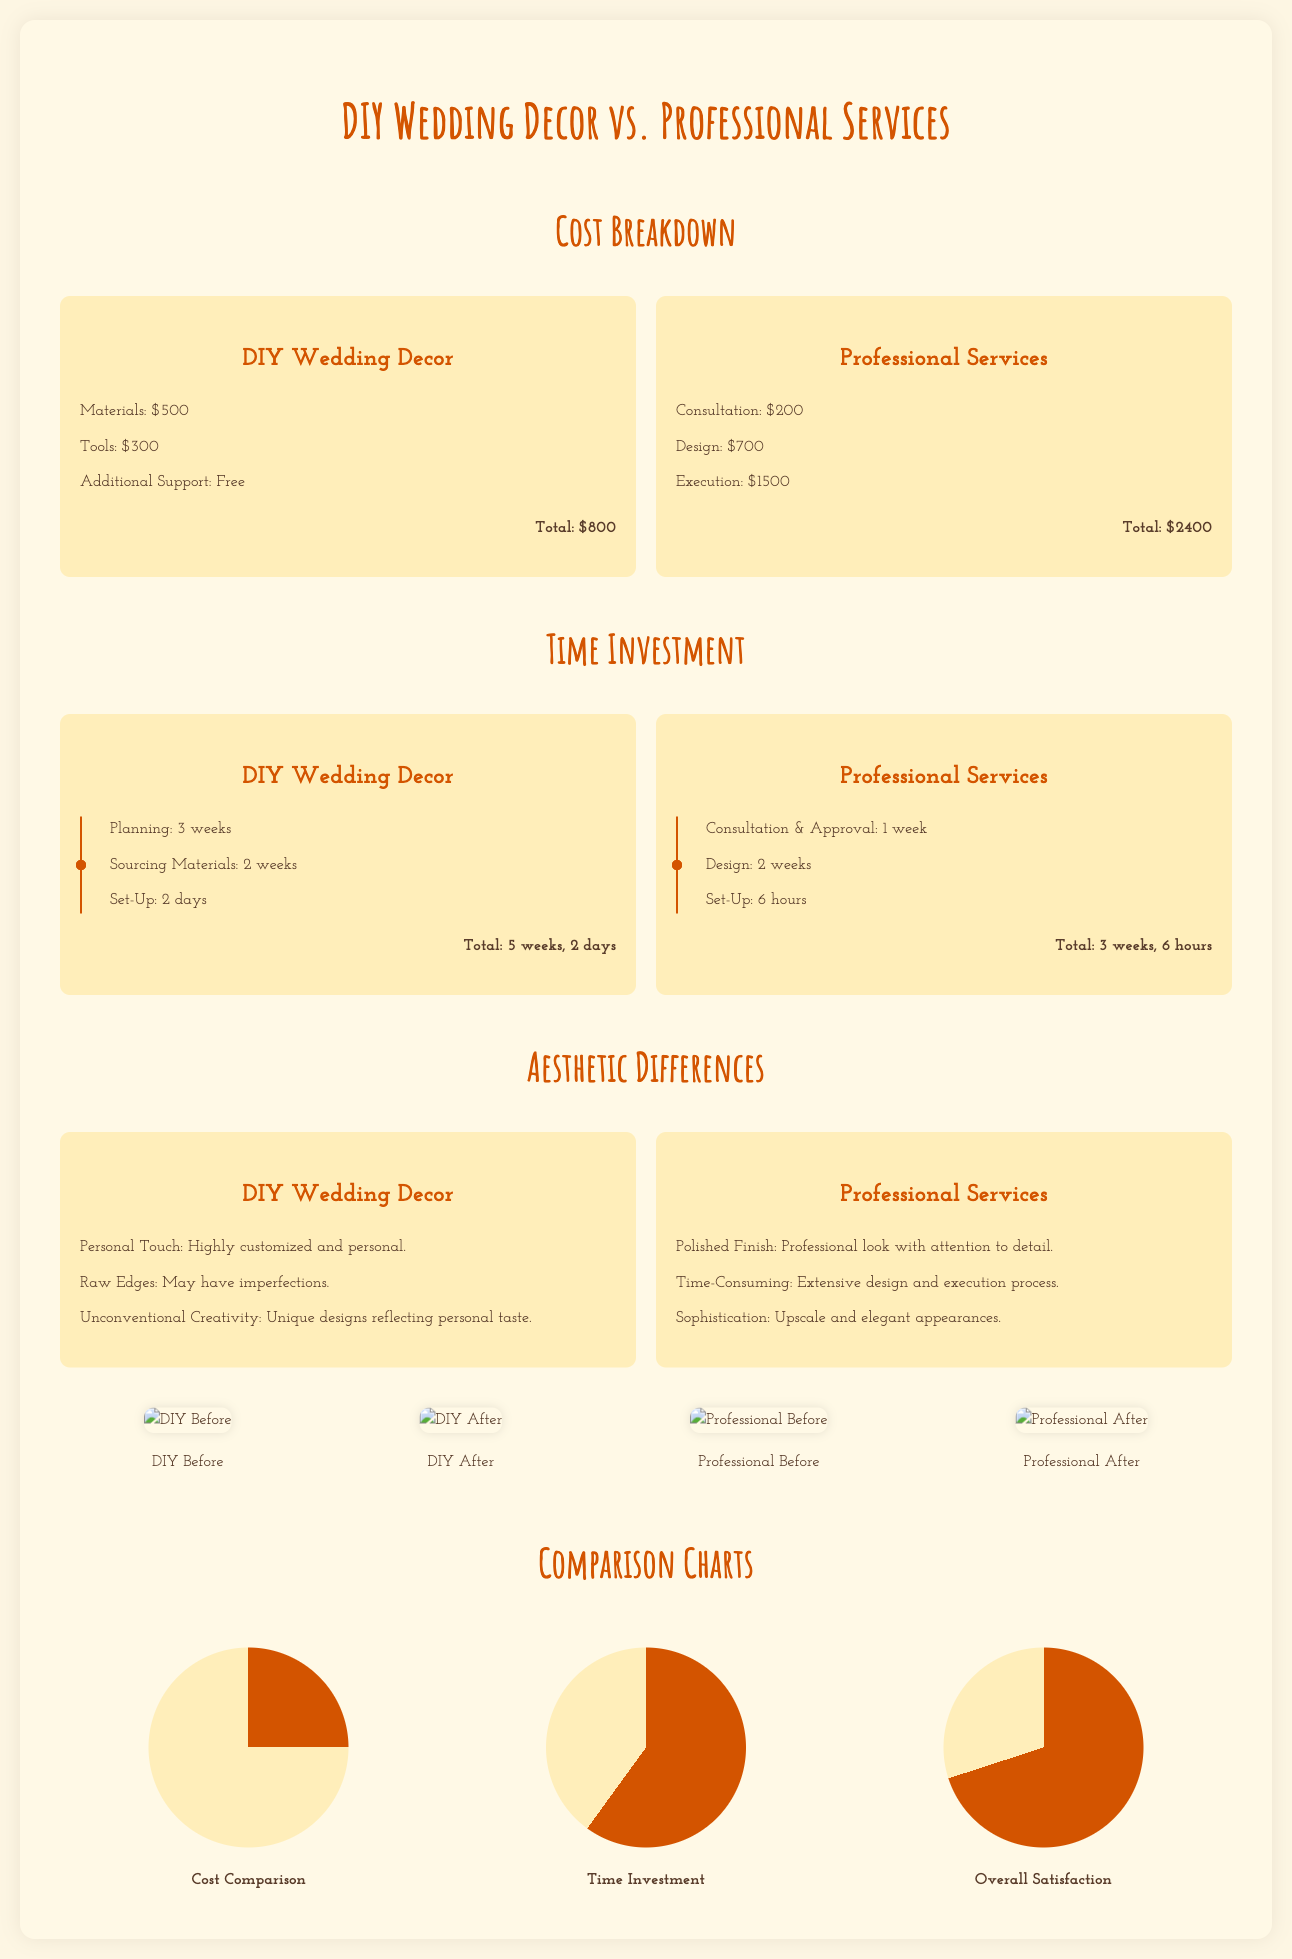What is the total cost of DIY Wedding Decor? The total cost is listed in the DIY Wedding Decor section as $800.
Answer: $800 What is the total cost of Professional Services? The total cost is listed in the Professional Services section as $2400.
Answer: $2400 How many weeks does the DIY Wedding Decor process take? The total time investment for DIY is summarized as 5 weeks and 2 days.
Answer: 5 weeks, 2 days What is the estimated setup time for Professional Services? The setup time listed in the Professional Services section is 6 hours.
Answer: 6 hours Which option has a more polished finish? The Professional Services section mentions a polished finish.
Answer: Professional Services What is the cost difference between DIY and Professional Services? The difference is calculated by subtracting the total cost of DIY from Professional Services, which is $2400 - $800 = $1600.
Answer: $1600 What personal aspect is emphasized in DIY Wedding Decor? The DIY Wedding Decor section emphasizes "Highly customized and personal."
Answer: Highly customized and personal Which category lists "Unconventional Creativity"? The phrase appears in the DIY Wedding Decor section regarding its aesthetic differences.
Answer: DIY Wedding Decor What aesthetic does Professional Services aim for? The section states that it aims for "Upscale and elegant appearances."
Answer: Upscale and elegant appearances 